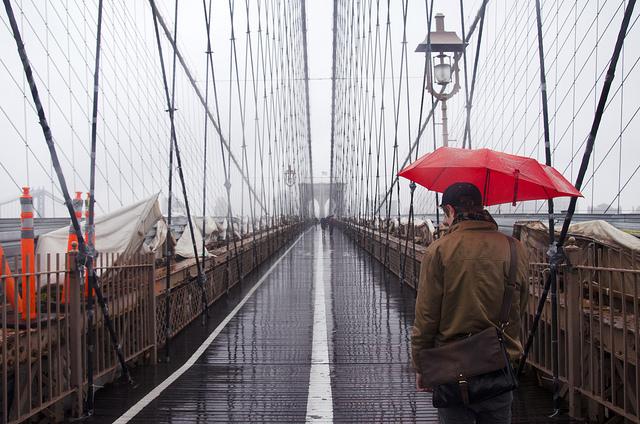Who is carrying a red umbrella?
Short answer required. Man. Is this black and white?
Short answer required. No. Where is he going?
Concise answer only. Across bridge. Is this a bridge for automobiles?
Be succinct. No. 